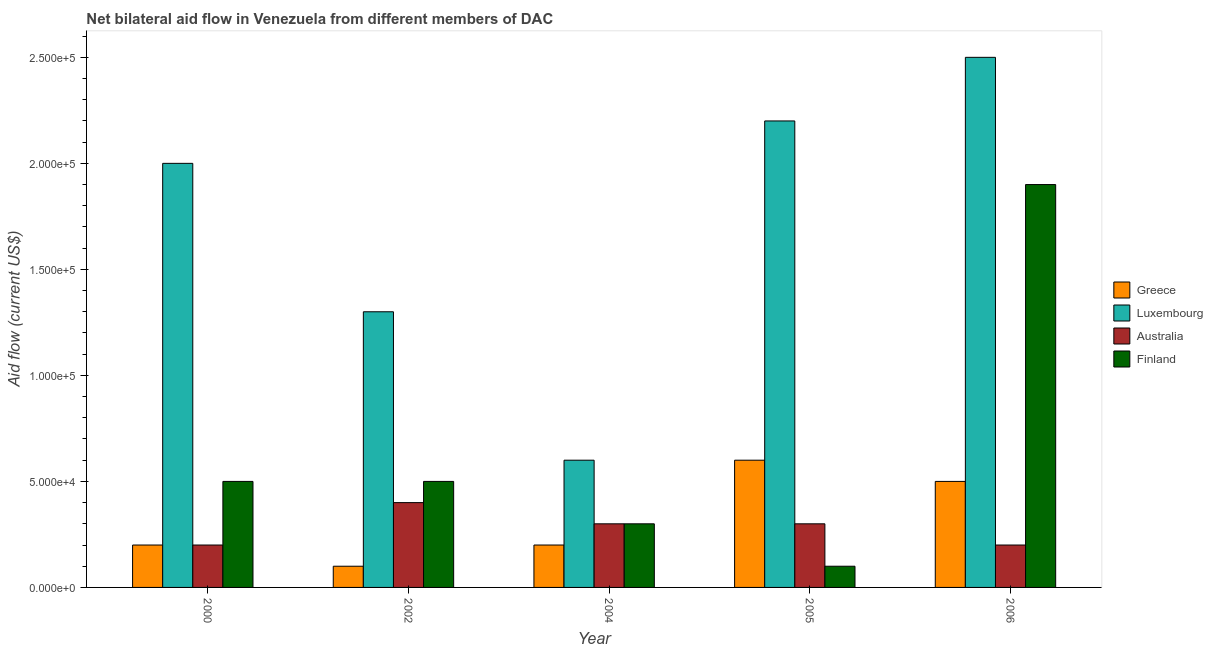How many different coloured bars are there?
Ensure brevity in your answer.  4. What is the amount of aid given by greece in 2005?
Offer a terse response. 6.00e+04. Across all years, what is the maximum amount of aid given by luxembourg?
Make the answer very short. 2.50e+05. Across all years, what is the minimum amount of aid given by luxembourg?
Provide a succinct answer. 6.00e+04. What is the total amount of aid given by luxembourg in the graph?
Offer a very short reply. 8.60e+05. What is the difference between the amount of aid given by finland in 2002 and that in 2005?
Offer a very short reply. 4.00e+04. What is the difference between the amount of aid given by australia in 2005 and the amount of aid given by greece in 2004?
Your answer should be compact. 0. What is the average amount of aid given by finland per year?
Your answer should be compact. 6.60e+04. In the year 2002, what is the difference between the amount of aid given by luxembourg and amount of aid given by finland?
Your answer should be compact. 0. What is the ratio of the amount of aid given by luxembourg in 2000 to that in 2004?
Offer a terse response. 3.33. Is the difference between the amount of aid given by greece in 2000 and 2006 greater than the difference between the amount of aid given by australia in 2000 and 2006?
Your response must be concise. No. What is the difference between the highest and the lowest amount of aid given by australia?
Your response must be concise. 2.00e+04. Is it the case that in every year, the sum of the amount of aid given by luxembourg and amount of aid given by australia is greater than the sum of amount of aid given by greece and amount of aid given by finland?
Make the answer very short. Yes. What does the 4th bar from the left in 2004 represents?
Make the answer very short. Finland. What does the 4th bar from the right in 2004 represents?
Make the answer very short. Greece. Is it the case that in every year, the sum of the amount of aid given by greece and amount of aid given by luxembourg is greater than the amount of aid given by australia?
Provide a succinct answer. Yes. Are the values on the major ticks of Y-axis written in scientific E-notation?
Your answer should be very brief. Yes. Does the graph contain any zero values?
Your response must be concise. No. Where does the legend appear in the graph?
Your response must be concise. Center right. How are the legend labels stacked?
Keep it short and to the point. Vertical. What is the title of the graph?
Your response must be concise. Net bilateral aid flow in Venezuela from different members of DAC. Does "Negligence towards children" appear as one of the legend labels in the graph?
Ensure brevity in your answer.  No. What is the label or title of the X-axis?
Offer a very short reply. Year. What is the Aid flow (current US$) in Finland in 2000?
Ensure brevity in your answer.  5.00e+04. What is the Aid flow (current US$) of Greece in 2002?
Provide a succinct answer. 10000. What is the Aid flow (current US$) of Finland in 2002?
Provide a short and direct response. 5.00e+04. What is the Aid flow (current US$) of Luxembourg in 2004?
Ensure brevity in your answer.  6.00e+04. What is the Aid flow (current US$) of Finland in 2004?
Your answer should be very brief. 3.00e+04. What is the Aid flow (current US$) in Greece in 2006?
Give a very brief answer. 5.00e+04. What is the Aid flow (current US$) in Luxembourg in 2006?
Offer a terse response. 2.50e+05. Across all years, what is the maximum Aid flow (current US$) in Australia?
Your answer should be compact. 4.00e+04. Across all years, what is the minimum Aid flow (current US$) in Greece?
Give a very brief answer. 10000. What is the total Aid flow (current US$) in Greece in the graph?
Provide a succinct answer. 1.60e+05. What is the total Aid flow (current US$) in Luxembourg in the graph?
Provide a short and direct response. 8.60e+05. What is the difference between the Aid flow (current US$) in Australia in 2000 and that in 2002?
Ensure brevity in your answer.  -2.00e+04. What is the difference between the Aid flow (current US$) of Finland in 2000 and that in 2002?
Keep it short and to the point. 0. What is the difference between the Aid flow (current US$) of Greece in 2000 and that in 2004?
Keep it short and to the point. 0. What is the difference between the Aid flow (current US$) of Luxembourg in 2000 and that in 2004?
Ensure brevity in your answer.  1.40e+05. What is the difference between the Aid flow (current US$) of Greece in 2000 and that in 2005?
Your answer should be compact. -4.00e+04. What is the difference between the Aid flow (current US$) of Luxembourg in 2000 and that in 2005?
Give a very brief answer. -2.00e+04. What is the difference between the Aid flow (current US$) in Australia in 2000 and that in 2005?
Provide a succinct answer. -10000. What is the difference between the Aid flow (current US$) in Finland in 2000 and that in 2005?
Offer a terse response. 4.00e+04. What is the difference between the Aid flow (current US$) in Greece in 2002 and that in 2004?
Provide a succinct answer. -10000. What is the difference between the Aid flow (current US$) of Luxembourg in 2002 and that in 2004?
Provide a short and direct response. 7.00e+04. What is the difference between the Aid flow (current US$) of Australia in 2002 and that in 2004?
Offer a very short reply. 10000. What is the difference between the Aid flow (current US$) in Finland in 2002 and that in 2004?
Offer a very short reply. 2.00e+04. What is the difference between the Aid flow (current US$) in Finland in 2002 and that in 2005?
Provide a succinct answer. 4.00e+04. What is the difference between the Aid flow (current US$) of Luxembourg in 2002 and that in 2006?
Your answer should be very brief. -1.20e+05. What is the difference between the Aid flow (current US$) of Australia in 2002 and that in 2006?
Keep it short and to the point. 2.00e+04. What is the difference between the Aid flow (current US$) of Luxembourg in 2004 and that in 2005?
Offer a very short reply. -1.60e+05. What is the difference between the Aid flow (current US$) of Australia in 2004 and that in 2005?
Give a very brief answer. 0. What is the difference between the Aid flow (current US$) in Greece in 2004 and that in 2006?
Offer a terse response. -3.00e+04. What is the difference between the Aid flow (current US$) in Finland in 2005 and that in 2006?
Provide a succinct answer. -1.80e+05. What is the difference between the Aid flow (current US$) in Greece in 2000 and the Aid flow (current US$) in Luxembourg in 2002?
Keep it short and to the point. -1.10e+05. What is the difference between the Aid flow (current US$) in Greece in 2000 and the Aid flow (current US$) in Finland in 2002?
Your answer should be very brief. -3.00e+04. What is the difference between the Aid flow (current US$) of Luxembourg in 2000 and the Aid flow (current US$) of Australia in 2002?
Provide a succinct answer. 1.60e+05. What is the difference between the Aid flow (current US$) of Greece in 2000 and the Aid flow (current US$) of Luxembourg in 2004?
Provide a succinct answer. -4.00e+04. What is the difference between the Aid flow (current US$) of Greece in 2000 and the Aid flow (current US$) of Finland in 2004?
Your response must be concise. -10000. What is the difference between the Aid flow (current US$) in Luxembourg in 2000 and the Aid flow (current US$) in Finland in 2004?
Offer a terse response. 1.70e+05. What is the difference between the Aid flow (current US$) of Greece in 2000 and the Aid flow (current US$) of Luxembourg in 2005?
Ensure brevity in your answer.  -2.00e+05. What is the difference between the Aid flow (current US$) in Greece in 2000 and the Aid flow (current US$) in Australia in 2005?
Your response must be concise. -10000. What is the difference between the Aid flow (current US$) of Greece in 2000 and the Aid flow (current US$) of Finland in 2005?
Offer a terse response. 10000. What is the difference between the Aid flow (current US$) of Greece in 2000 and the Aid flow (current US$) of Australia in 2006?
Provide a short and direct response. 0. What is the difference between the Aid flow (current US$) of Luxembourg in 2000 and the Aid flow (current US$) of Australia in 2006?
Make the answer very short. 1.80e+05. What is the difference between the Aid flow (current US$) of Greece in 2002 and the Aid flow (current US$) of Luxembourg in 2004?
Your answer should be very brief. -5.00e+04. What is the difference between the Aid flow (current US$) of Greece in 2002 and the Aid flow (current US$) of Australia in 2004?
Give a very brief answer. -2.00e+04. What is the difference between the Aid flow (current US$) in Greece in 2002 and the Aid flow (current US$) in Finland in 2004?
Your answer should be compact. -2.00e+04. What is the difference between the Aid flow (current US$) in Luxembourg in 2002 and the Aid flow (current US$) in Australia in 2004?
Your answer should be compact. 1.00e+05. What is the difference between the Aid flow (current US$) of Australia in 2002 and the Aid flow (current US$) of Finland in 2004?
Your response must be concise. 10000. What is the difference between the Aid flow (current US$) of Greece in 2002 and the Aid flow (current US$) of Luxembourg in 2005?
Offer a terse response. -2.10e+05. What is the difference between the Aid flow (current US$) in Greece in 2002 and the Aid flow (current US$) in Finland in 2005?
Ensure brevity in your answer.  0. What is the difference between the Aid flow (current US$) in Australia in 2002 and the Aid flow (current US$) in Finland in 2005?
Keep it short and to the point. 3.00e+04. What is the difference between the Aid flow (current US$) in Greece in 2002 and the Aid flow (current US$) in Australia in 2006?
Offer a very short reply. -10000. What is the difference between the Aid flow (current US$) in Greece in 2002 and the Aid flow (current US$) in Finland in 2006?
Offer a terse response. -1.80e+05. What is the difference between the Aid flow (current US$) in Luxembourg in 2002 and the Aid flow (current US$) in Australia in 2006?
Your response must be concise. 1.10e+05. What is the difference between the Aid flow (current US$) in Greece in 2004 and the Aid flow (current US$) in Finland in 2005?
Your answer should be very brief. 10000. What is the difference between the Aid flow (current US$) of Luxembourg in 2004 and the Aid flow (current US$) of Australia in 2005?
Your answer should be very brief. 3.00e+04. What is the difference between the Aid flow (current US$) of Luxembourg in 2004 and the Aid flow (current US$) of Finland in 2005?
Ensure brevity in your answer.  5.00e+04. What is the difference between the Aid flow (current US$) of Greece in 2004 and the Aid flow (current US$) of Luxembourg in 2006?
Give a very brief answer. -2.30e+05. What is the difference between the Aid flow (current US$) in Greece in 2004 and the Aid flow (current US$) in Australia in 2006?
Offer a very short reply. 0. What is the difference between the Aid flow (current US$) in Greece in 2004 and the Aid flow (current US$) in Finland in 2006?
Give a very brief answer. -1.70e+05. What is the difference between the Aid flow (current US$) in Luxembourg in 2004 and the Aid flow (current US$) in Australia in 2006?
Ensure brevity in your answer.  4.00e+04. What is the difference between the Aid flow (current US$) of Greece in 2005 and the Aid flow (current US$) of Australia in 2006?
Keep it short and to the point. 4.00e+04. What is the difference between the Aid flow (current US$) in Luxembourg in 2005 and the Aid flow (current US$) in Finland in 2006?
Keep it short and to the point. 3.00e+04. What is the difference between the Aid flow (current US$) of Australia in 2005 and the Aid flow (current US$) of Finland in 2006?
Give a very brief answer. -1.60e+05. What is the average Aid flow (current US$) of Greece per year?
Keep it short and to the point. 3.20e+04. What is the average Aid flow (current US$) in Luxembourg per year?
Offer a very short reply. 1.72e+05. What is the average Aid flow (current US$) in Australia per year?
Offer a very short reply. 2.80e+04. What is the average Aid flow (current US$) in Finland per year?
Offer a very short reply. 6.60e+04. In the year 2000, what is the difference between the Aid flow (current US$) of Greece and Aid flow (current US$) of Luxembourg?
Offer a terse response. -1.80e+05. In the year 2000, what is the difference between the Aid flow (current US$) in Luxembourg and Aid flow (current US$) in Australia?
Give a very brief answer. 1.80e+05. In the year 2000, what is the difference between the Aid flow (current US$) of Luxembourg and Aid flow (current US$) of Finland?
Your answer should be very brief. 1.50e+05. In the year 2002, what is the difference between the Aid flow (current US$) of Greece and Aid flow (current US$) of Luxembourg?
Ensure brevity in your answer.  -1.20e+05. In the year 2002, what is the difference between the Aid flow (current US$) in Greece and Aid flow (current US$) in Finland?
Make the answer very short. -4.00e+04. In the year 2002, what is the difference between the Aid flow (current US$) of Luxembourg and Aid flow (current US$) of Australia?
Keep it short and to the point. 9.00e+04. In the year 2002, what is the difference between the Aid flow (current US$) of Luxembourg and Aid flow (current US$) of Finland?
Your answer should be very brief. 8.00e+04. In the year 2002, what is the difference between the Aid flow (current US$) in Australia and Aid flow (current US$) in Finland?
Offer a very short reply. -10000. In the year 2005, what is the difference between the Aid flow (current US$) in Greece and Aid flow (current US$) in Luxembourg?
Your answer should be compact. -1.60e+05. In the year 2005, what is the difference between the Aid flow (current US$) in Greece and Aid flow (current US$) in Australia?
Your response must be concise. 3.00e+04. In the year 2005, what is the difference between the Aid flow (current US$) in Greece and Aid flow (current US$) in Finland?
Keep it short and to the point. 5.00e+04. In the year 2005, what is the difference between the Aid flow (current US$) of Australia and Aid flow (current US$) of Finland?
Give a very brief answer. 2.00e+04. In the year 2006, what is the difference between the Aid flow (current US$) in Greece and Aid flow (current US$) in Luxembourg?
Keep it short and to the point. -2.00e+05. In the year 2006, what is the difference between the Aid flow (current US$) of Greece and Aid flow (current US$) of Australia?
Your response must be concise. 3.00e+04. In the year 2006, what is the difference between the Aid flow (current US$) in Greece and Aid flow (current US$) in Finland?
Provide a short and direct response. -1.40e+05. In the year 2006, what is the difference between the Aid flow (current US$) in Luxembourg and Aid flow (current US$) in Australia?
Ensure brevity in your answer.  2.30e+05. In the year 2006, what is the difference between the Aid flow (current US$) of Australia and Aid flow (current US$) of Finland?
Provide a succinct answer. -1.70e+05. What is the ratio of the Aid flow (current US$) of Luxembourg in 2000 to that in 2002?
Ensure brevity in your answer.  1.54. What is the ratio of the Aid flow (current US$) in Finland in 2000 to that in 2002?
Your answer should be compact. 1. What is the ratio of the Aid flow (current US$) in Greece in 2000 to that in 2004?
Offer a terse response. 1. What is the ratio of the Aid flow (current US$) of Finland in 2000 to that in 2004?
Offer a very short reply. 1.67. What is the ratio of the Aid flow (current US$) in Luxembourg in 2000 to that in 2005?
Keep it short and to the point. 0.91. What is the ratio of the Aid flow (current US$) in Australia in 2000 to that in 2005?
Offer a terse response. 0.67. What is the ratio of the Aid flow (current US$) in Finland in 2000 to that in 2005?
Offer a very short reply. 5. What is the ratio of the Aid flow (current US$) of Greece in 2000 to that in 2006?
Your answer should be compact. 0.4. What is the ratio of the Aid flow (current US$) of Australia in 2000 to that in 2006?
Offer a very short reply. 1. What is the ratio of the Aid flow (current US$) in Finland in 2000 to that in 2006?
Your answer should be very brief. 0.26. What is the ratio of the Aid flow (current US$) of Luxembourg in 2002 to that in 2004?
Give a very brief answer. 2.17. What is the ratio of the Aid flow (current US$) of Australia in 2002 to that in 2004?
Ensure brevity in your answer.  1.33. What is the ratio of the Aid flow (current US$) of Greece in 2002 to that in 2005?
Make the answer very short. 0.17. What is the ratio of the Aid flow (current US$) in Luxembourg in 2002 to that in 2005?
Your answer should be compact. 0.59. What is the ratio of the Aid flow (current US$) of Australia in 2002 to that in 2005?
Make the answer very short. 1.33. What is the ratio of the Aid flow (current US$) in Greece in 2002 to that in 2006?
Your answer should be very brief. 0.2. What is the ratio of the Aid flow (current US$) of Luxembourg in 2002 to that in 2006?
Keep it short and to the point. 0.52. What is the ratio of the Aid flow (current US$) of Finland in 2002 to that in 2006?
Keep it short and to the point. 0.26. What is the ratio of the Aid flow (current US$) of Greece in 2004 to that in 2005?
Your answer should be very brief. 0.33. What is the ratio of the Aid flow (current US$) in Luxembourg in 2004 to that in 2005?
Offer a very short reply. 0.27. What is the ratio of the Aid flow (current US$) of Finland in 2004 to that in 2005?
Offer a terse response. 3. What is the ratio of the Aid flow (current US$) of Luxembourg in 2004 to that in 2006?
Your answer should be compact. 0.24. What is the ratio of the Aid flow (current US$) of Finland in 2004 to that in 2006?
Provide a short and direct response. 0.16. What is the ratio of the Aid flow (current US$) of Greece in 2005 to that in 2006?
Keep it short and to the point. 1.2. What is the ratio of the Aid flow (current US$) in Luxembourg in 2005 to that in 2006?
Offer a terse response. 0.88. What is the ratio of the Aid flow (current US$) in Australia in 2005 to that in 2006?
Keep it short and to the point. 1.5. What is the ratio of the Aid flow (current US$) of Finland in 2005 to that in 2006?
Provide a succinct answer. 0.05. What is the difference between the highest and the second highest Aid flow (current US$) of Finland?
Make the answer very short. 1.40e+05. What is the difference between the highest and the lowest Aid flow (current US$) in Greece?
Ensure brevity in your answer.  5.00e+04. What is the difference between the highest and the lowest Aid flow (current US$) in Australia?
Provide a succinct answer. 2.00e+04. What is the difference between the highest and the lowest Aid flow (current US$) of Finland?
Offer a very short reply. 1.80e+05. 